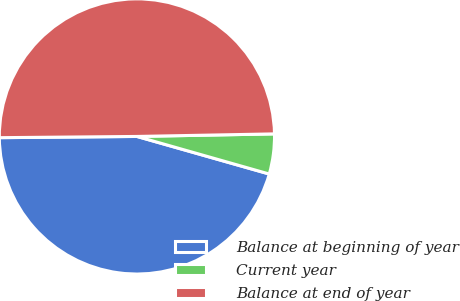<chart> <loc_0><loc_0><loc_500><loc_500><pie_chart><fcel>Balance at beginning of year<fcel>Current year<fcel>Balance at end of year<nl><fcel>45.45%<fcel>4.7%<fcel>49.84%<nl></chart> 